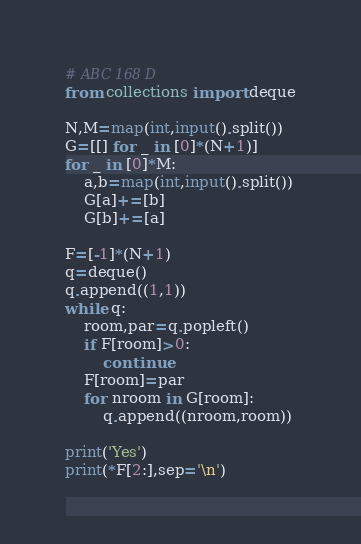<code> <loc_0><loc_0><loc_500><loc_500><_Python_># ABC 168 D
from collections import deque

N,M=map(int,input().split())
G=[[] for _ in [0]*(N+1)]
for _ in [0]*M:
    a,b=map(int,input().split())
    G[a]+=[b]
    G[b]+=[a]

F=[-1]*(N+1)
q=deque()
q.append((1,1))
while q:
    room,par=q.popleft()
    if F[room]>0:
        continue
    F[room]=par
    for nroom in G[room]:
        q.append((nroom,room))
        
print('Yes')
print(*F[2:],sep='\n')</code> 